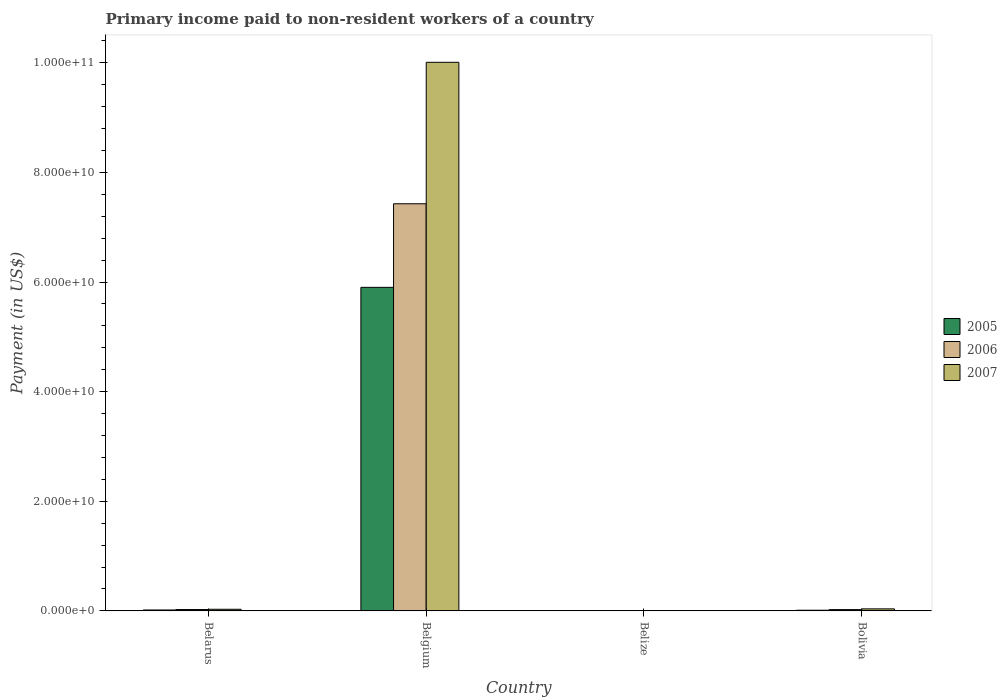How many different coloured bars are there?
Offer a very short reply. 3. How many groups of bars are there?
Give a very brief answer. 4. How many bars are there on the 1st tick from the right?
Your response must be concise. 3. In how many cases, is the number of bars for a given country not equal to the number of legend labels?
Make the answer very short. 0. What is the amount paid to workers in 2005 in Belize?
Your answer should be very brief. 6.78e+06. Across all countries, what is the maximum amount paid to workers in 2007?
Your response must be concise. 1.00e+11. Across all countries, what is the minimum amount paid to workers in 2005?
Offer a terse response. 6.78e+06. In which country was the amount paid to workers in 2005 maximum?
Give a very brief answer. Belgium. In which country was the amount paid to workers in 2006 minimum?
Offer a terse response. Belize. What is the total amount paid to workers in 2006 in the graph?
Ensure brevity in your answer.  7.48e+1. What is the difference between the amount paid to workers in 2007 in Belize and that in Bolivia?
Your answer should be very brief. -3.63e+08. What is the difference between the amount paid to workers in 2006 in Belgium and the amount paid to workers in 2007 in Belarus?
Offer a terse response. 7.40e+1. What is the average amount paid to workers in 2005 per country?
Your answer should be compact. 1.48e+1. What is the difference between the amount paid to workers of/in 2006 and amount paid to workers of/in 2005 in Belgium?
Offer a very short reply. 1.52e+1. In how many countries, is the amount paid to workers in 2006 greater than 64000000000 US$?
Provide a succinct answer. 1. What is the ratio of the amount paid to workers in 2007 in Belarus to that in Bolivia?
Your answer should be compact. 0.8. Is the difference between the amount paid to workers in 2006 in Belarus and Belize greater than the difference between the amount paid to workers in 2005 in Belarus and Belize?
Offer a terse response. Yes. What is the difference between the highest and the second highest amount paid to workers in 2007?
Your answer should be very brief. 9.98e+1. What is the difference between the highest and the lowest amount paid to workers in 2005?
Offer a terse response. 5.90e+1. Is it the case that in every country, the sum of the amount paid to workers in 2006 and amount paid to workers in 2005 is greater than the amount paid to workers in 2007?
Your answer should be very brief. No. How many bars are there?
Provide a short and direct response. 12. How many countries are there in the graph?
Provide a short and direct response. 4. What is the difference between two consecutive major ticks on the Y-axis?
Make the answer very short. 2.00e+1. Are the values on the major ticks of Y-axis written in scientific E-notation?
Keep it short and to the point. Yes. Does the graph contain any zero values?
Your answer should be compact. No. How many legend labels are there?
Offer a very short reply. 3. How are the legend labels stacked?
Your answer should be compact. Vertical. What is the title of the graph?
Provide a succinct answer. Primary income paid to non-resident workers of a country. Does "2002" appear as one of the legend labels in the graph?
Make the answer very short. No. What is the label or title of the X-axis?
Your answer should be very brief. Country. What is the label or title of the Y-axis?
Offer a terse response. Payment (in US$). What is the Payment (in US$) of 2005 in Belarus?
Your answer should be very brief. 1.68e+08. What is the Payment (in US$) of 2006 in Belarus?
Make the answer very short. 2.47e+08. What is the Payment (in US$) in 2007 in Belarus?
Give a very brief answer. 2.97e+08. What is the Payment (in US$) of 2005 in Belgium?
Provide a succinct answer. 5.90e+1. What is the Payment (in US$) in 2006 in Belgium?
Offer a very short reply. 7.43e+1. What is the Payment (in US$) of 2007 in Belgium?
Your response must be concise. 1.00e+11. What is the Payment (in US$) of 2005 in Belize?
Provide a succinct answer. 6.78e+06. What is the Payment (in US$) in 2006 in Belize?
Give a very brief answer. 1.01e+07. What is the Payment (in US$) in 2007 in Belize?
Ensure brevity in your answer.  6.97e+06. What is the Payment (in US$) in 2005 in Bolivia?
Ensure brevity in your answer.  1.21e+08. What is the Payment (in US$) of 2006 in Bolivia?
Provide a succinct answer. 2.35e+08. What is the Payment (in US$) of 2007 in Bolivia?
Offer a terse response. 3.70e+08. Across all countries, what is the maximum Payment (in US$) in 2005?
Provide a succinct answer. 5.90e+1. Across all countries, what is the maximum Payment (in US$) of 2006?
Offer a very short reply. 7.43e+1. Across all countries, what is the maximum Payment (in US$) in 2007?
Give a very brief answer. 1.00e+11. Across all countries, what is the minimum Payment (in US$) of 2005?
Offer a terse response. 6.78e+06. Across all countries, what is the minimum Payment (in US$) in 2006?
Ensure brevity in your answer.  1.01e+07. Across all countries, what is the minimum Payment (in US$) of 2007?
Your response must be concise. 6.97e+06. What is the total Payment (in US$) in 2005 in the graph?
Give a very brief answer. 5.93e+1. What is the total Payment (in US$) of 2006 in the graph?
Offer a terse response. 7.48e+1. What is the total Payment (in US$) of 2007 in the graph?
Your answer should be compact. 1.01e+11. What is the difference between the Payment (in US$) of 2005 in Belarus and that in Belgium?
Give a very brief answer. -5.89e+1. What is the difference between the Payment (in US$) in 2006 in Belarus and that in Belgium?
Provide a short and direct response. -7.40e+1. What is the difference between the Payment (in US$) of 2007 in Belarus and that in Belgium?
Make the answer very short. -9.98e+1. What is the difference between the Payment (in US$) in 2005 in Belarus and that in Belize?
Your response must be concise. 1.62e+08. What is the difference between the Payment (in US$) of 2006 in Belarus and that in Belize?
Make the answer very short. 2.36e+08. What is the difference between the Payment (in US$) in 2007 in Belarus and that in Belize?
Give a very brief answer. 2.90e+08. What is the difference between the Payment (in US$) of 2005 in Belarus and that in Bolivia?
Provide a short and direct response. 4.72e+07. What is the difference between the Payment (in US$) in 2006 in Belarus and that in Bolivia?
Make the answer very short. 1.12e+07. What is the difference between the Payment (in US$) of 2007 in Belarus and that in Bolivia?
Offer a terse response. -7.27e+07. What is the difference between the Payment (in US$) in 2005 in Belgium and that in Belize?
Ensure brevity in your answer.  5.90e+1. What is the difference between the Payment (in US$) in 2006 in Belgium and that in Belize?
Your answer should be very brief. 7.43e+1. What is the difference between the Payment (in US$) in 2007 in Belgium and that in Belize?
Make the answer very short. 1.00e+11. What is the difference between the Payment (in US$) of 2005 in Belgium and that in Bolivia?
Make the answer very short. 5.89e+1. What is the difference between the Payment (in US$) of 2006 in Belgium and that in Bolivia?
Ensure brevity in your answer.  7.40e+1. What is the difference between the Payment (in US$) of 2007 in Belgium and that in Bolivia?
Ensure brevity in your answer.  9.97e+1. What is the difference between the Payment (in US$) of 2005 in Belize and that in Bolivia?
Keep it short and to the point. -1.14e+08. What is the difference between the Payment (in US$) of 2006 in Belize and that in Bolivia?
Offer a very short reply. -2.25e+08. What is the difference between the Payment (in US$) of 2007 in Belize and that in Bolivia?
Ensure brevity in your answer.  -3.63e+08. What is the difference between the Payment (in US$) of 2005 in Belarus and the Payment (in US$) of 2006 in Belgium?
Offer a terse response. -7.41e+1. What is the difference between the Payment (in US$) of 2005 in Belarus and the Payment (in US$) of 2007 in Belgium?
Ensure brevity in your answer.  -9.99e+1. What is the difference between the Payment (in US$) of 2006 in Belarus and the Payment (in US$) of 2007 in Belgium?
Provide a succinct answer. -9.98e+1. What is the difference between the Payment (in US$) in 2005 in Belarus and the Payment (in US$) in 2006 in Belize?
Your response must be concise. 1.58e+08. What is the difference between the Payment (in US$) in 2005 in Belarus and the Payment (in US$) in 2007 in Belize?
Keep it short and to the point. 1.61e+08. What is the difference between the Payment (in US$) of 2006 in Belarus and the Payment (in US$) of 2007 in Belize?
Offer a terse response. 2.40e+08. What is the difference between the Payment (in US$) of 2005 in Belarus and the Payment (in US$) of 2006 in Bolivia?
Give a very brief answer. -6.70e+07. What is the difference between the Payment (in US$) of 2005 in Belarus and the Payment (in US$) of 2007 in Bolivia?
Provide a short and direct response. -2.01e+08. What is the difference between the Payment (in US$) in 2006 in Belarus and the Payment (in US$) in 2007 in Bolivia?
Your answer should be very brief. -1.23e+08. What is the difference between the Payment (in US$) of 2005 in Belgium and the Payment (in US$) of 2006 in Belize?
Your response must be concise. 5.90e+1. What is the difference between the Payment (in US$) of 2005 in Belgium and the Payment (in US$) of 2007 in Belize?
Offer a very short reply. 5.90e+1. What is the difference between the Payment (in US$) of 2006 in Belgium and the Payment (in US$) of 2007 in Belize?
Give a very brief answer. 7.43e+1. What is the difference between the Payment (in US$) in 2005 in Belgium and the Payment (in US$) in 2006 in Bolivia?
Provide a short and direct response. 5.88e+1. What is the difference between the Payment (in US$) in 2005 in Belgium and the Payment (in US$) in 2007 in Bolivia?
Keep it short and to the point. 5.87e+1. What is the difference between the Payment (in US$) of 2006 in Belgium and the Payment (in US$) of 2007 in Bolivia?
Ensure brevity in your answer.  7.39e+1. What is the difference between the Payment (in US$) of 2005 in Belize and the Payment (in US$) of 2006 in Bolivia?
Your answer should be compact. -2.29e+08. What is the difference between the Payment (in US$) of 2005 in Belize and the Payment (in US$) of 2007 in Bolivia?
Ensure brevity in your answer.  -3.63e+08. What is the difference between the Payment (in US$) of 2006 in Belize and the Payment (in US$) of 2007 in Bolivia?
Make the answer very short. -3.60e+08. What is the average Payment (in US$) of 2005 per country?
Offer a terse response. 1.48e+1. What is the average Payment (in US$) in 2006 per country?
Provide a short and direct response. 1.87e+1. What is the average Payment (in US$) in 2007 per country?
Offer a very short reply. 2.52e+1. What is the difference between the Payment (in US$) in 2005 and Payment (in US$) in 2006 in Belarus?
Make the answer very short. -7.82e+07. What is the difference between the Payment (in US$) in 2005 and Payment (in US$) in 2007 in Belarus?
Provide a short and direct response. -1.29e+08. What is the difference between the Payment (in US$) in 2006 and Payment (in US$) in 2007 in Belarus?
Give a very brief answer. -5.05e+07. What is the difference between the Payment (in US$) of 2005 and Payment (in US$) of 2006 in Belgium?
Offer a very short reply. -1.52e+1. What is the difference between the Payment (in US$) in 2005 and Payment (in US$) in 2007 in Belgium?
Provide a short and direct response. -4.11e+1. What is the difference between the Payment (in US$) of 2006 and Payment (in US$) of 2007 in Belgium?
Offer a very short reply. -2.58e+1. What is the difference between the Payment (in US$) in 2005 and Payment (in US$) in 2006 in Belize?
Provide a short and direct response. -3.32e+06. What is the difference between the Payment (in US$) in 2005 and Payment (in US$) in 2007 in Belize?
Provide a short and direct response. -1.86e+05. What is the difference between the Payment (in US$) in 2006 and Payment (in US$) in 2007 in Belize?
Provide a succinct answer. 3.13e+06. What is the difference between the Payment (in US$) of 2005 and Payment (in US$) of 2006 in Bolivia?
Your answer should be compact. -1.14e+08. What is the difference between the Payment (in US$) in 2005 and Payment (in US$) in 2007 in Bolivia?
Offer a very short reply. -2.49e+08. What is the difference between the Payment (in US$) of 2006 and Payment (in US$) of 2007 in Bolivia?
Your answer should be compact. -1.34e+08. What is the ratio of the Payment (in US$) of 2005 in Belarus to that in Belgium?
Provide a short and direct response. 0. What is the ratio of the Payment (in US$) of 2006 in Belarus to that in Belgium?
Give a very brief answer. 0. What is the ratio of the Payment (in US$) in 2007 in Belarus to that in Belgium?
Offer a very short reply. 0. What is the ratio of the Payment (in US$) of 2005 in Belarus to that in Belize?
Offer a very short reply. 24.83. What is the ratio of the Payment (in US$) in 2006 in Belarus to that in Belize?
Offer a terse response. 24.41. What is the ratio of the Payment (in US$) of 2007 in Belarus to that in Belize?
Your response must be concise. 42.65. What is the ratio of the Payment (in US$) of 2005 in Belarus to that in Bolivia?
Provide a short and direct response. 1.39. What is the ratio of the Payment (in US$) of 2006 in Belarus to that in Bolivia?
Make the answer very short. 1.05. What is the ratio of the Payment (in US$) in 2007 in Belarus to that in Bolivia?
Keep it short and to the point. 0.8. What is the ratio of the Payment (in US$) of 2005 in Belgium to that in Belize?
Give a very brief answer. 8704.96. What is the ratio of the Payment (in US$) in 2006 in Belgium to that in Belize?
Your response must be concise. 7353.89. What is the ratio of the Payment (in US$) of 2007 in Belgium to that in Belize?
Your answer should be very brief. 1.44e+04. What is the ratio of the Payment (in US$) of 2005 in Belgium to that in Bolivia?
Make the answer very short. 486.92. What is the ratio of the Payment (in US$) in 2006 in Belgium to that in Bolivia?
Your response must be concise. 315.48. What is the ratio of the Payment (in US$) in 2007 in Belgium to that in Bolivia?
Provide a succinct answer. 270.62. What is the ratio of the Payment (in US$) in 2005 in Belize to that in Bolivia?
Keep it short and to the point. 0.06. What is the ratio of the Payment (in US$) of 2006 in Belize to that in Bolivia?
Your answer should be very brief. 0.04. What is the ratio of the Payment (in US$) in 2007 in Belize to that in Bolivia?
Give a very brief answer. 0.02. What is the difference between the highest and the second highest Payment (in US$) in 2005?
Provide a succinct answer. 5.89e+1. What is the difference between the highest and the second highest Payment (in US$) in 2006?
Your answer should be compact. 7.40e+1. What is the difference between the highest and the second highest Payment (in US$) in 2007?
Make the answer very short. 9.97e+1. What is the difference between the highest and the lowest Payment (in US$) of 2005?
Make the answer very short. 5.90e+1. What is the difference between the highest and the lowest Payment (in US$) of 2006?
Give a very brief answer. 7.43e+1. What is the difference between the highest and the lowest Payment (in US$) of 2007?
Offer a very short reply. 1.00e+11. 